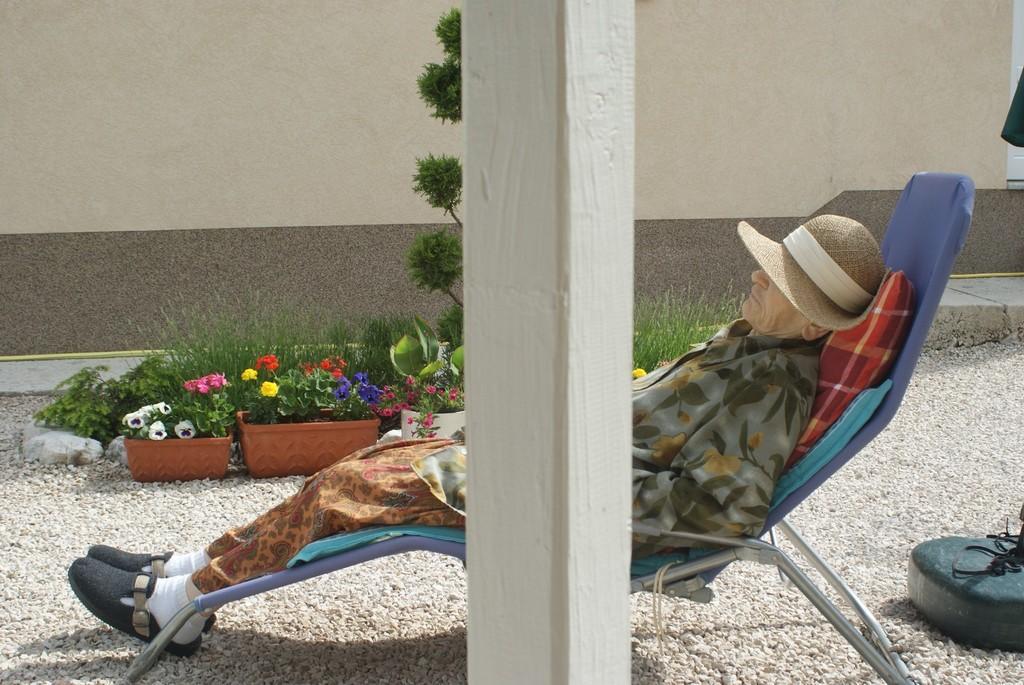How would you summarize this image in a sentence or two? In this picture there is an old man, he is sleeping on the rocking chair and there is a pillar in the center of the image and there are plants in the background area of the image. 